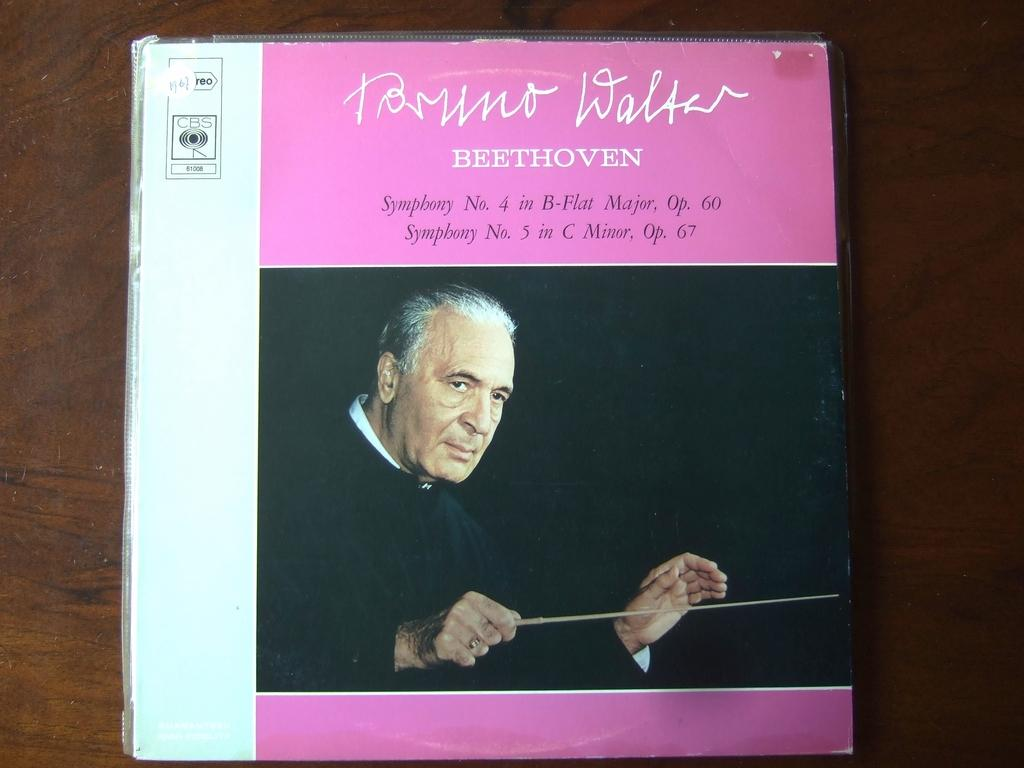<image>
Offer a succinct explanation of the picture presented. A CD box with the word Beethoven on the front . 